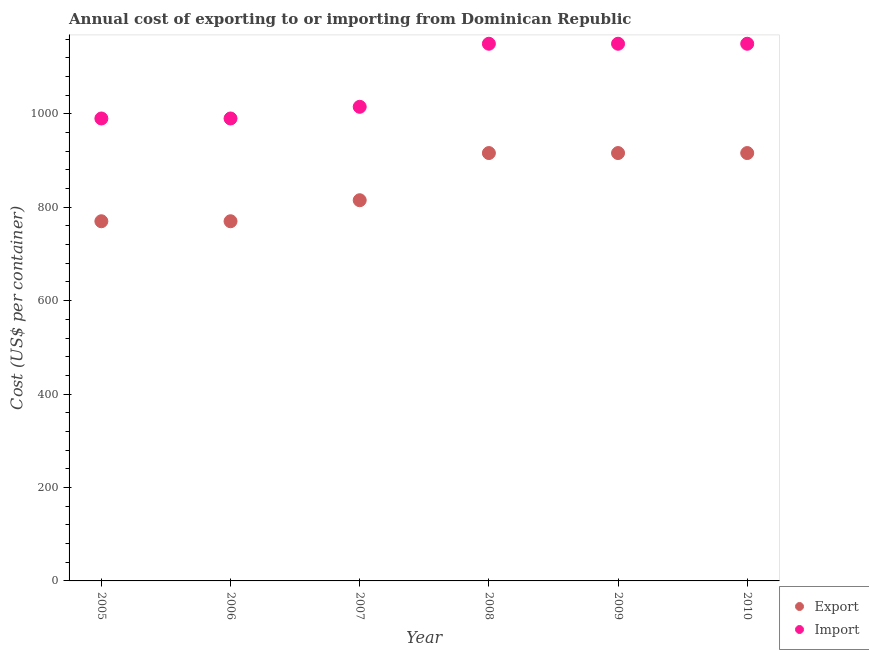What is the import cost in 2005?
Your answer should be compact. 990. Across all years, what is the maximum export cost?
Your response must be concise. 916. Across all years, what is the minimum import cost?
Offer a terse response. 990. In which year was the export cost minimum?
Offer a terse response. 2005. What is the total import cost in the graph?
Keep it short and to the point. 6445. What is the difference between the import cost in 2005 and that in 2009?
Make the answer very short. -160. What is the difference between the import cost in 2007 and the export cost in 2008?
Your answer should be very brief. 99. What is the average export cost per year?
Your answer should be compact. 850.5. In the year 2007, what is the difference between the import cost and export cost?
Your answer should be very brief. 200. What is the ratio of the import cost in 2007 to that in 2009?
Keep it short and to the point. 0.88. Is the import cost in 2005 less than that in 2008?
Your answer should be very brief. Yes. What is the difference between the highest and the second highest export cost?
Your answer should be compact. 0. What is the difference between the highest and the lowest export cost?
Give a very brief answer. 146. Is the sum of the export cost in 2006 and 2008 greater than the maximum import cost across all years?
Keep it short and to the point. Yes. Does the export cost monotonically increase over the years?
Your answer should be very brief. No. Is the import cost strictly greater than the export cost over the years?
Make the answer very short. Yes. How many years are there in the graph?
Offer a terse response. 6. What is the difference between two consecutive major ticks on the Y-axis?
Give a very brief answer. 200. Does the graph contain grids?
Your answer should be very brief. No. How many legend labels are there?
Your answer should be very brief. 2. How are the legend labels stacked?
Provide a succinct answer. Vertical. What is the title of the graph?
Keep it short and to the point. Annual cost of exporting to or importing from Dominican Republic. What is the label or title of the X-axis?
Provide a succinct answer. Year. What is the label or title of the Y-axis?
Offer a terse response. Cost (US$ per container). What is the Cost (US$ per container) in Export in 2005?
Keep it short and to the point. 770. What is the Cost (US$ per container) of Import in 2005?
Offer a very short reply. 990. What is the Cost (US$ per container) in Export in 2006?
Your answer should be compact. 770. What is the Cost (US$ per container) in Import in 2006?
Offer a terse response. 990. What is the Cost (US$ per container) in Export in 2007?
Give a very brief answer. 815. What is the Cost (US$ per container) in Import in 2007?
Offer a very short reply. 1015. What is the Cost (US$ per container) of Export in 2008?
Your answer should be compact. 916. What is the Cost (US$ per container) of Import in 2008?
Your answer should be compact. 1150. What is the Cost (US$ per container) in Export in 2009?
Offer a terse response. 916. What is the Cost (US$ per container) in Import in 2009?
Give a very brief answer. 1150. What is the Cost (US$ per container) in Export in 2010?
Provide a succinct answer. 916. What is the Cost (US$ per container) of Import in 2010?
Provide a short and direct response. 1150. Across all years, what is the maximum Cost (US$ per container) in Export?
Offer a very short reply. 916. Across all years, what is the maximum Cost (US$ per container) in Import?
Offer a very short reply. 1150. Across all years, what is the minimum Cost (US$ per container) in Export?
Provide a succinct answer. 770. Across all years, what is the minimum Cost (US$ per container) in Import?
Provide a succinct answer. 990. What is the total Cost (US$ per container) in Export in the graph?
Offer a terse response. 5103. What is the total Cost (US$ per container) in Import in the graph?
Offer a terse response. 6445. What is the difference between the Cost (US$ per container) of Export in 2005 and that in 2007?
Offer a terse response. -45. What is the difference between the Cost (US$ per container) of Export in 2005 and that in 2008?
Provide a succinct answer. -146. What is the difference between the Cost (US$ per container) of Import in 2005 and that in 2008?
Your answer should be very brief. -160. What is the difference between the Cost (US$ per container) of Export in 2005 and that in 2009?
Ensure brevity in your answer.  -146. What is the difference between the Cost (US$ per container) in Import in 2005 and that in 2009?
Offer a very short reply. -160. What is the difference between the Cost (US$ per container) in Export in 2005 and that in 2010?
Your answer should be compact. -146. What is the difference between the Cost (US$ per container) of Import in 2005 and that in 2010?
Your answer should be compact. -160. What is the difference between the Cost (US$ per container) in Export in 2006 and that in 2007?
Ensure brevity in your answer.  -45. What is the difference between the Cost (US$ per container) of Export in 2006 and that in 2008?
Offer a terse response. -146. What is the difference between the Cost (US$ per container) of Import in 2006 and that in 2008?
Offer a terse response. -160. What is the difference between the Cost (US$ per container) in Export in 2006 and that in 2009?
Provide a succinct answer. -146. What is the difference between the Cost (US$ per container) in Import in 2006 and that in 2009?
Offer a very short reply. -160. What is the difference between the Cost (US$ per container) in Export in 2006 and that in 2010?
Provide a succinct answer. -146. What is the difference between the Cost (US$ per container) of Import in 2006 and that in 2010?
Offer a terse response. -160. What is the difference between the Cost (US$ per container) of Export in 2007 and that in 2008?
Your answer should be very brief. -101. What is the difference between the Cost (US$ per container) of Import in 2007 and that in 2008?
Provide a succinct answer. -135. What is the difference between the Cost (US$ per container) in Export in 2007 and that in 2009?
Ensure brevity in your answer.  -101. What is the difference between the Cost (US$ per container) of Import in 2007 and that in 2009?
Make the answer very short. -135. What is the difference between the Cost (US$ per container) of Export in 2007 and that in 2010?
Ensure brevity in your answer.  -101. What is the difference between the Cost (US$ per container) in Import in 2007 and that in 2010?
Offer a terse response. -135. What is the difference between the Cost (US$ per container) of Export in 2008 and that in 2009?
Provide a succinct answer. 0. What is the difference between the Cost (US$ per container) of Export in 2009 and that in 2010?
Give a very brief answer. 0. What is the difference between the Cost (US$ per container) in Export in 2005 and the Cost (US$ per container) in Import in 2006?
Your answer should be very brief. -220. What is the difference between the Cost (US$ per container) of Export in 2005 and the Cost (US$ per container) of Import in 2007?
Make the answer very short. -245. What is the difference between the Cost (US$ per container) of Export in 2005 and the Cost (US$ per container) of Import in 2008?
Offer a very short reply. -380. What is the difference between the Cost (US$ per container) in Export in 2005 and the Cost (US$ per container) in Import in 2009?
Give a very brief answer. -380. What is the difference between the Cost (US$ per container) in Export in 2005 and the Cost (US$ per container) in Import in 2010?
Your answer should be very brief. -380. What is the difference between the Cost (US$ per container) in Export in 2006 and the Cost (US$ per container) in Import in 2007?
Offer a very short reply. -245. What is the difference between the Cost (US$ per container) in Export in 2006 and the Cost (US$ per container) in Import in 2008?
Provide a succinct answer. -380. What is the difference between the Cost (US$ per container) of Export in 2006 and the Cost (US$ per container) of Import in 2009?
Provide a short and direct response. -380. What is the difference between the Cost (US$ per container) of Export in 2006 and the Cost (US$ per container) of Import in 2010?
Your answer should be very brief. -380. What is the difference between the Cost (US$ per container) in Export in 2007 and the Cost (US$ per container) in Import in 2008?
Keep it short and to the point. -335. What is the difference between the Cost (US$ per container) in Export in 2007 and the Cost (US$ per container) in Import in 2009?
Offer a terse response. -335. What is the difference between the Cost (US$ per container) in Export in 2007 and the Cost (US$ per container) in Import in 2010?
Make the answer very short. -335. What is the difference between the Cost (US$ per container) in Export in 2008 and the Cost (US$ per container) in Import in 2009?
Your response must be concise. -234. What is the difference between the Cost (US$ per container) of Export in 2008 and the Cost (US$ per container) of Import in 2010?
Provide a short and direct response. -234. What is the difference between the Cost (US$ per container) of Export in 2009 and the Cost (US$ per container) of Import in 2010?
Your answer should be compact. -234. What is the average Cost (US$ per container) in Export per year?
Provide a short and direct response. 850.5. What is the average Cost (US$ per container) of Import per year?
Keep it short and to the point. 1074.17. In the year 2005, what is the difference between the Cost (US$ per container) of Export and Cost (US$ per container) of Import?
Provide a succinct answer. -220. In the year 2006, what is the difference between the Cost (US$ per container) of Export and Cost (US$ per container) of Import?
Ensure brevity in your answer.  -220. In the year 2007, what is the difference between the Cost (US$ per container) in Export and Cost (US$ per container) in Import?
Your response must be concise. -200. In the year 2008, what is the difference between the Cost (US$ per container) in Export and Cost (US$ per container) in Import?
Your response must be concise. -234. In the year 2009, what is the difference between the Cost (US$ per container) of Export and Cost (US$ per container) of Import?
Your answer should be very brief. -234. In the year 2010, what is the difference between the Cost (US$ per container) of Export and Cost (US$ per container) of Import?
Make the answer very short. -234. What is the ratio of the Cost (US$ per container) of Export in 2005 to that in 2006?
Ensure brevity in your answer.  1. What is the ratio of the Cost (US$ per container) in Import in 2005 to that in 2006?
Offer a terse response. 1. What is the ratio of the Cost (US$ per container) in Export in 2005 to that in 2007?
Make the answer very short. 0.94. What is the ratio of the Cost (US$ per container) of Import in 2005 to that in 2007?
Ensure brevity in your answer.  0.98. What is the ratio of the Cost (US$ per container) in Export in 2005 to that in 2008?
Your answer should be very brief. 0.84. What is the ratio of the Cost (US$ per container) in Import in 2005 to that in 2008?
Your answer should be compact. 0.86. What is the ratio of the Cost (US$ per container) of Export in 2005 to that in 2009?
Provide a short and direct response. 0.84. What is the ratio of the Cost (US$ per container) of Import in 2005 to that in 2009?
Your response must be concise. 0.86. What is the ratio of the Cost (US$ per container) of Export in 2005 to that in 2010?
Ensure brevity in your answer.  0.84. What is the ratio of the Cost (US$ per container) of Import in 2005 to that in 2010?
Your answer should be very brief. 0.86. What is the ratio of the Cost (US$ per container) of Export in 2006 to that in 2007?
Your answer should be compact. 0.94. What is the ratio of the Cost (US$ per container) of Import in 2006 to that in 2007?
Offer a terse response. 0.98. What is the ratio of the Cost (US$ per container) of Export in 2006 to that in 2008?
Give a very brief answer. 0.84. What is the ratio of the Cost (US$ per container) in Import in 2006 to that in 2008?
Keep it short and to the point. 0.86. What is the ratio of the Cost (US$ per container) in Export in 2006 to that in 2009?
Give a very brief answer. 0.84. What is the ratio of the Cost (US$ per container) in Import in 2006 to that in 2009?
Provide a short and direct response. 0.86. What is the ratio of the Cost (US$ per container) in Export in 2006 to that in 2010?
Give a very brief answer. 0.84. What is the ratio of the Cost (US$ per container) in Import in 2006 to that in 2010?
Keep it short and to the point. 0.86. What is the ratio of the Cost (US$ per container) of Export in 2007 to that in 2008?
Provide a succinct answer. 0.89. What is the ratio of the Cost (US$ per container) in Import in 2007 to that in 2008?
Offer a terse response. 0.88. What is the ratio of the Cost (US$ per container) of Export in 2007 to that in 2009?
Give a very brief answer. 0.89. What is the ratio of the Cost (US$ per container) of Import in 2007 to that in 2009?
Your response must be concise. 0.88. What is the ratio of the Cost (US$ per container) of Export in 2007 to that in 2010?
Provide a succinct answer. 0.89. What is the ratio of the Cost (US$ per container) of Import in 2007 to that in 2010?
Offer a terse response. 0.88. What is the ratio of the Cost (US$ per container) of Export in 2008 to that in 2009?
Your response must be concise. 1. What is the ratio of the Cost (US$ per container) in Export in 2009 to that in 2010?
Ensure brevity in your answer.  1. What is the difference between the highest and the second highest Cost (US$ per container) in Export?
Ensure brevity in your answer.  0. What is the difference between the highest and the second highest Cost (US$ per container) in Import?
Offer a terse response. 0. What is the difference between the highest and the lowest Cost (US$ per container) of Export?
Your answer should be very brief. 146. What is the difference between the highest and the lowest Cost (US$ per container) of Import?
Your response must be concise. 160. 